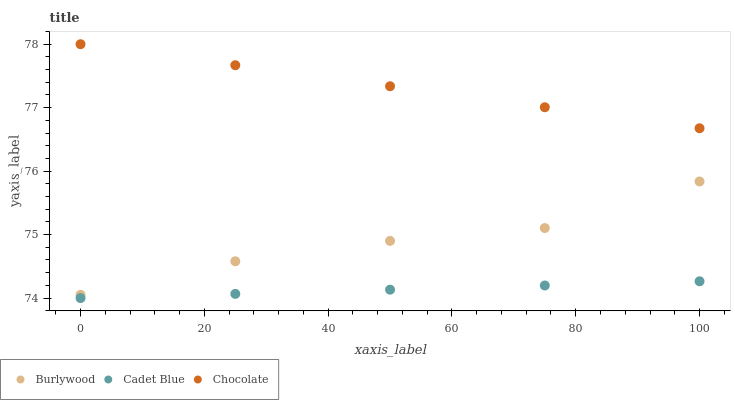Does Cadet Blue have the minimum area under the curve?
Answer yes or no. Yes. Does Chocolate have the maximum area under the curve?
Answer yes or no. Yes. Does Chocolate have the minimum area under the curve?
Answer yes or no. No. Does Cadet Blue have the maximum area under the curve?
Answer yes or no. No. Is Chocolate the smoothest?
Answer yes or no. Yes. Is Burlywood the roughest?
Answer yes or no. Yes. Is Cadet Blue the smoothest?
Answer yes or no. No. Is Cadet Blue the roughest?
Answer yes or no. No. Does Cadet Blue have the lowest value?
Answer yes or no. Yes. Does Chocolate have the lowest value?
Answer yes or no. No. Does Chocolate have the highest value?
Answer yes or no. Yes. Does Cadet Blue have the highest value?
Answer yes or no. No. Is Cadet Blue less than Burlywood?
Answer yes or no. Yes. Is Chocolate greater than Burlywood?
Answer yes or no. Yes. Does Cadet Blue intersect Burlywood?
Answer yes or no. No. 